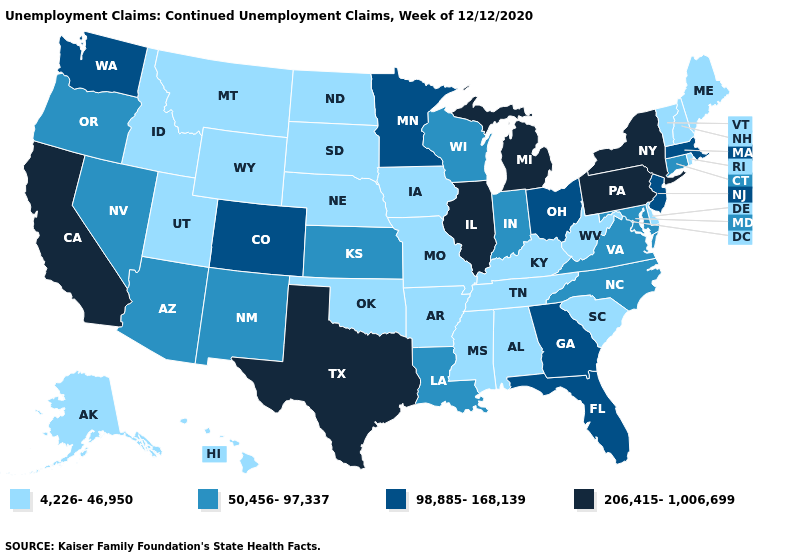Does Hawaii have a higher value than Rhode Island?
Give a very brief answer. No. Does California have the highest value in the West?
Short answer required. Yes. Does Delaware have the lowest value in the USA?
Keep it brief. Yes. Does Kansas have the lowest value in the MidWest?
Give a very brief answer. No. Name the states that have a value in the range 4,226-46,950?
Be succinct. Alabama, Alaska, Arkansas, Delaware, Hawaii, Idaho, Iowa, Kentucky, Maine, Mississippi, Missouri, Montana, Nebraska, New Hampshire, North Dakota, Oklahoma, Rhode Island, South Carolina, South Dakota, Tennessee, Utah, Vermont, West Virginia, Wyoming. Is the legend a continuous bar?
Answer briefly. No. Does the first symbol in the legend represent the smallest category?
Keep it brief. Yes. Which states hav the highest value in the MidWest?
Quick response, please. Illinois, Michigan. Name the states that have a value in the range 4,226-46,950?
Write a very short answer. Alabama, Alaska, Arkansas, Delaware, Hawaii, Idaho, Iowa, Kentucky, Maine, Mississippi, Missouri, Montana, Nebraska, New Hampshire, North Dakota, Oklahoma, Rhode Island, South Carolina, South Dakota, Tennessee, Utah, Vermont, West Virginia, Wyoming. What is the value of Rhode Island?
Keep it brief. 4,226-46,950. Among the states that border Oregon , which have the highest value?
Keep it brief. California. What is the highest value in states that border Kentucky?
Concise answer only. 206,415-1,006,699. Does the first symbol in the legend represent the smallest category?
Quick response, please. Yes. Does Pennsylvania have a higher value than Louisiana?
Quick response, please. Yes. What is the value of New Jersey?
Quick response, please. 98,885-168,139. 